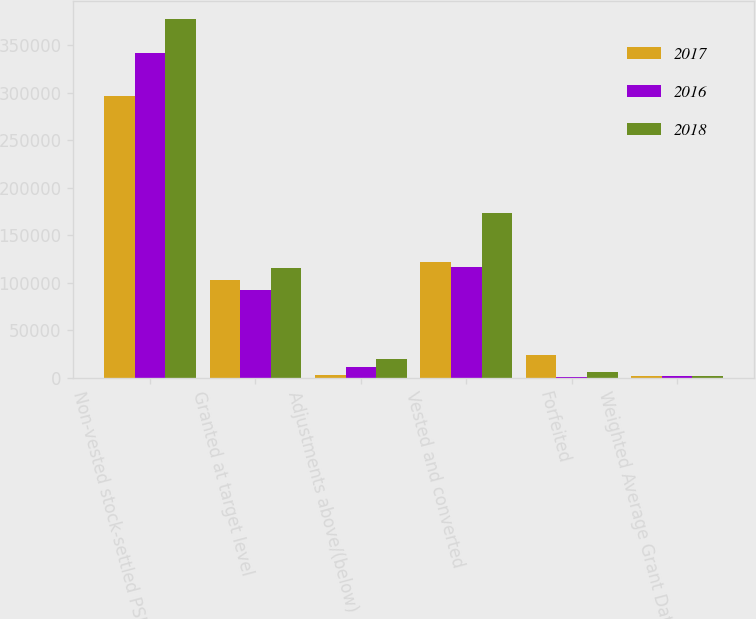<chart> <loc_0><loc_0><loc_500><loc_500><stacked_bar_chart><ecel><fcel>Non-vested stock-settled PSU<fcel>Granted at target level<fcel>Adjustments above/(below)<fcel>Vested and converted<fcel>Forfeited<fcel>Weighted Average Grant Date<nl><fcel>2017<fcel>296037<fcel>102307<fcel>2284<fcel>121984<fcel>23946<fcel>2018<nl><fcel>2016<fcel>341944<fcel>92045<fcel>11369<fcel>116684<fcel>110<fcel>2017<nl><fcel>2018<fcel>378062<fcel>115035<fcel>19339<fcel>173364<fcel>5674<fcel>2016<nl></chart> 